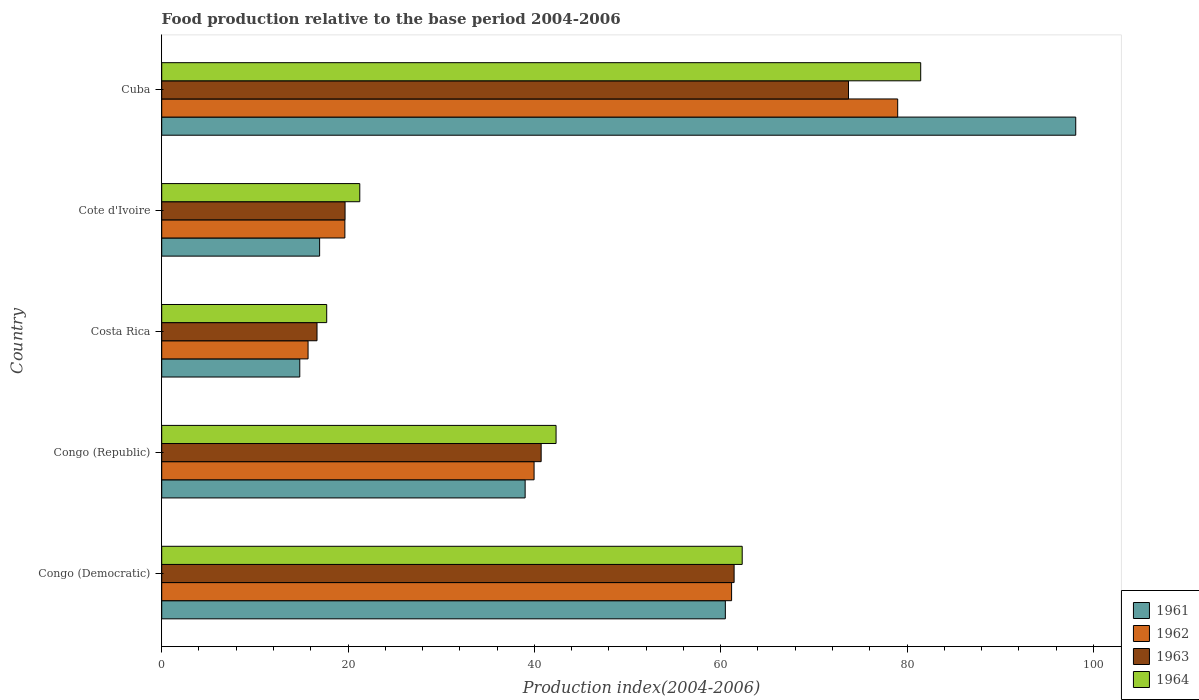How many different coloured bars are there?
Your answer should be compact. 4. How many groups of bars are there?
Make the answer very short. 5. Are the number of bars on each tick of the Y-axis equal?
Offer a very short reply. Yes. How many bars are there on the 2nd tick from the top?
Make the answer very short. 4. What is the label of the 1st group of bars from the top?
Provide a short and direct response. Cuba. In how many cases, is the number of bars for a given country not equal to the number of legend labels?
Give a very brief answer. 0. What is the food production index in 1964 in Cuba?
Provide a short and direct response. 81.47. Across all countries, what is the maximum food production index in 1962?
Provide a short and direct response. 79. Across all countries, what is the minimum food production index in 1962?
Make the answer very short. 15.71. In which country was the food production index in 1964 maximum?
Provide a succinct answer. Cuba. What is the total food production index in 1963 in the graph?
Provide a succinct answer. 212.24. What is the difference between the food production index in 1963 in Congo (Democratic) and that in Cuba?
Keep it short and to the point. -12.28. What is the difference between the food production index in 1964 in Congo (Democratic) and the food production index in 1961 in Cote d'Ivoire?
Offer a very short reply. 45.36. What is the average food production index in 1964 per country?
Your answer should be compact. 45.02. What is the difference between the food production index in 1961 and food production index in 1962 in Cuba?
Ensure brevity in your answer.  19.11. In how many countries, is the food production index in 1961 greater than 28 ?
Provide a short and direct response. 3. What is the ratio of the food production index in 1964 in Congo (Republic) to that in Cote d'Ivoire?
Keep it short and to the point. 1.99. Is the difference between the food production index in 1961 in Costa Rica and Cote d'Ivoire greater than the difference between the food production index in 1962 in Costa Rica and Cote d'Ivoire?
Ensure brevity in your answer.  Yes. What is the difference between the highest and the second highest food production index in 1962?
Ensure brevity in your answer.  17.83. What is the difference between the highest and the lowest food production index in 1963?
Keep it short and to the point. 57.05. In how many countries, is the food production index in 1961 greater than the average food production index in 1961 taken over all countries?
Your response must be concise. 2. Is the sum of the food production index in 1961 in Congo (Democratic) and Costa Rica greater than the maximum food production index in 1963 across all countries?
Provide a short and direct response. Yes. What does the 3rd bar from the bottom in Costa Rica represents?
Provide a short and direct response. 1963. How many bars are there?
Provide a short and direct response. 20. Does the graph contain any zero values?
Offer a very short reply. No. Does the graph contain grids?
Your answer should be very brief. No. How many legend labels are there?
Offer a terse response. 4. How are the legend labels stacked?
Keep it short and to the point. Vertical. What is the title of the graph?
Offer a terse response. Food production relative to the base period 2004-2006. Does "2000" appear as one of the legend labels in the graph?
Offer a terse response. No. What is the label or title of the X-axis?
Keep it short and to the point. Production index(2004-2006). What is the Production index(2004-2006) of 1961 in Congo (Democratic)?
Make the answer very short. 60.5. What is the Production index(2004-2006) in 1962 in Congo (Democratic)?
Your answer should be very brief. 61.17. What is the Production index(2004-2006) in 1963 in Congo (Democratic)?
Offer a very short reply. 61.44. What is the Production index(2004-2006) in 1964 in Congo (Democratic)?
Keep it short and to the point. 62.31. What is the Production index(2004-2006) in 1961 in Congo (Republic)?
Your answer should be very brief. 39.01. What is the Production index(2004-2006) of 1962 in Congo (Republic)?
Your answer should be compact. 39.97. What is the Production index(2004-2006) in 1963 in Congo (Republic)?
Give a very brief answer. 40.73. What is the Production index(2004-2006) in 1964 in Congo (Republic)?
Give a very brief answer. 42.33. What is the Production index(2004-2006) of 1961 in Costa Rica?
Give a very brief answer. 14.82. What is the Production index(2004-2006) of 1962 in Costa Rica?
Offer a very short reply. 15.71. What is the Production index(2004-2006) in 1963 in Costa Rica?
Your answer should be compact. 16.67. What is the Production index(2004-2006) in 1964 in Costa Rica?
Offer a terse response. 17.71. What is the Production index(2004-2006) in 1961 in Cote d'Ivoire?
Your answer should be very brief. 16.95. What is the Production index(2004-2006) of 1962 in Cote d'Ivoire?
Offer a very short reply. 19.66. What is the Production index(2004-2006) in 1963 in Cote d'Ivoire?
Provide a short and direct response. 19.68. What is the Production index(2004-2006) of 1964 in Cote d'Ivoire?
Ensure brevity in your answer.  21.26. What is the Production index(2004-2006) of 1961 in Cuba?
Ensure brevity in your answer.  98.11. What is the Production index(2004-2006) in 1962 in Cuba?
Your answer should be compact. 79. What is the Production index(2004-2006) of 1963 in Cuba?
Your response must be concise. 73.72. What is the Production index(2004-2006) of 1964 in Cuba?
Offer a very short reply. 81.47. Across all countries, what is the maximum Production index(2004-2006) of 1961?
Your answer should be very brief. 98.11. Across all countries, what is the maximum Production index(2004-2006) in 1962?
Offer a very short reply. 79. Across all countries, what is the maximum Production index(2004-2006) of 1963?
Your response must be concise. 73.72. Across all countries, what is the maximum Production index(2004-2006) of 1964?
Keep it short and to the point. 81.47. Across all countries, what is the minimum Production index(2004-2006) of 1961?
Provide a short and direct response. 14.82. Across all countries, what is the minimum Production index(2004-2006) in 1962?
Provide a short and direct response. 15.71. Across all countries, what is the minimum Production index(2004-2006) of 1963?
Ensure brevity in your answer.  16.67. Across all countries, what is the minimum Production index(2004-2006) of 1964?
Make the answer very short. 17.71. What is the total Production index(2004-2006) of 1961 in the graph?
Give a very brief answer. 229.39. What is the total Production index(2004-2006) of 1962 in the graph?
Give a very brief answer. 215.51. What is the total Production index(2004-2006) of 1963 in the graph?
Offer a very short reply. 212.24. What is the total Production index(2004-2006) of 1964 in the graph?
Make the answer very short. 225.08. What is the difference between the Production index(2004-2006) in 1961 in Congo (Democratic) and that in Congo (Republic)?
Offer a terse response. 21.49. What is the difference between the Production index(2004-2006) in 1962 in Congo (Democratic) and that in Congo (Republic)?
Provide a succinct answer. 21.2. What is the difference between the Production index(2004-2006) of 1963 in Congo (Democratic) and that in Congo (Republic)?
Make the answer very short. 20.71. What is the difference between the Production index(2004-2006) in 1964 in Congo (Democratic) and that in Congo (Republic)?
Your response must be concise. 19.98. What is the difference between the Production index(2004-2006) in 1961 in Congo (Democratic) and that in Costa Rica?
Your response must be concise. 45.68. What is the difference between the Production index(2004-2006) of 1962 in Congo (Democratic) and that in Costa Rica?
Your answer should be very brief. 45.46. What is the difference between the Production index(2004-2006) of 1963 in Congo (Democratic) and that in Costa Rica?
Give a very brief answer. 44.77. What is the difference between the Production index(2004-2006) in 1964 in Congo (Democratic) and that in Costa Rica?
Provide a succinct answer. 44.6. What is the difference between the Production index(2004-2006) of 1961 in Congo (Democratic) and that in Cote d'Ivoire?
Offer a terse response. 43.55. What is the difference between the Production index(2004-2006) of 1962 in Congo (Democratic) and that in Cote d'Ivoire?
Offer a very short reply. 41.51. What is the difference between the Production index(2004-2006) in 1963 in Congo (Democratic) and that in Cote d'Ivoire?
Offer a very short reply. 41.76. What is the difference between the Production index(2004-2006) of 1964 in Congo (Democratic) and that in Cote d'Ivoire?
Your answer should be compact. 41.05. What is the difference between the Production index(2004-2006) of 1961 in Congo (Democratic) and that in Cuba?
Make the answer very short. -37.61. What is the difference between the Production index(2004-2006) in 1962 in Congo (Democratic) and that in Cuba?
Your answer should be very brief. -17.83. What is the difference between the Production index(2004-2006) in 1963 in Congo (Democratic) and that in Cuba?
Make the answer very short. -12.28. What is the difference between the Production index(2004-2006) in 1964 in Congo (Democratic) and that in Cuba?
Your answer should be very brief. -19.16. What is the difference between the Production index(2004-2006) in 1961 in Congo (Republic) and that in Costa Rica?
Offer a terse response. 24.19. What is the difference between the Production index(2004-2006) of 1962 in Congo (Republic) and that in Costa Rica?
Your response must be concise. 24.26. What is the difference between the Production index(2004-2006) of 1963 in Congo (Republic) and that in Costa Rica?
Provide a succinct answer. 24.06. What is the difference between the Production index(2004-2006) in 1964 in Congo (Republic) and that in Costa Rica?
Your answer should be very brief. 24.62. What is the difference between the Production index(2004-2006) in 1961 in Congo (Republic) and that in Cote d'Ivoire?
Ensure brevity in your answer.  22.06. What is the difference between the Production index(2004-2006) in 1962 in Congo (Republic) and that in Cote d'Ivoire?
Your answer should be compact. 20.31. What is the difference between the Production index(2004-2006) in 1963 in Congo (Republic) and that in Cote d'Ivoire?
Provide a short and direct response. 21.05. What is the difference between the Production index(2004-2006) of 1964 in Congo (Republic) and that in Cote d'Ivoire?
Offer a very short reply. 21.07. What is the difference between the Production index(2004-2006) of 1961 in Congo (Republic) and that in Cuba?
Your answer should be compact. -59.1. What is the difference between the Production index(2004-2006) in 1962 in Congo (Republic) and that in Cuba?
Your answer should be very brief. -39.03. What is the difference between the Production index(2004-2006) of 1963 in Congo (Republic) and that in Cuba?
Offer a terse response. -32.99. What is the difference between the Production index(2004-2006) of 1964 in Congo (Republic) and that in Cuba?
Offer a very short reply. -39.14. What is the difference between the Production index(2004-2006) in 1961 in Costa Rica and that in Cote d'Ivoire?
Provide a succinct answer. -2.13. What is the difference between the Production index(2004-2006) in 1962 in Costa Rica and that in Cote d'Ivoire?
Offer a very short reply. -3.95. What is the difference between the Production index(2004-2006) of 1963 in Costa Rica and that in Cote d'Ivoire?
Provide a short and direct response. -3.01. What is the difference between the Production index(2004-2006) of 1964 in Costa Rica and that in Cote d'Ivoire?
Your answer should be compact. -3.55. What is the difference between the Production index(2004-2006) in 1961 in Costa Rica and that in Cuba?
Give a very brief answer. -83.29. What is the difference between the Production index(2004-2006) in 1962 in Costa Rica and that in Cuba?
Your answer should be compact. -63.29. What is the difference between the Production index(2004-2006) of 1963 in Costa Rica and that in Cuba?
Offer a terse response. -57.05. What is the difference between the Production index(2004-2006) in 1964 in Costa Rica and that in Cuba?
Your response must be concise. -63.76. What is the difference between the Production index(2004-2006) in 1961 in Cote d'Ivoire and that in Cuba?
Provide a short and direct response. -81.16. What is the difference between the Production index(2004-2006) in 1962 in Cote d'Ivoire and that in Cuba?
Provide a short and direct response. -59.34. What is the difference between the Production index(2004-2006) in 1963 in Cote d'Ivoire and that in Cuba?
Ensure brevity in your answer.  -54.04. What is the difference between the Production index(2004-2006) in 1964 in Cote d'Ivoire and that in Cuba?
Provide a short and direct response. -60.21. What is the difference between the Production index(2004-2006) in 1961 in Congo (Democratic) and the Production index(2004-2006) in 1962 in Congo (Republic)?
Provide a short and direct response. 20.53. What is the difference between the Production index(2004-2006) in 1961 in Congo (Democratic) and the Production index(2004-2006) in 1963 in Congo (Republic)?
Provide a short and direct response. 19.77. What is the difference between the Production index(2004-2006) of 1961 in Congo (Democratic) and the Production index(2004-2006) of 1964 in Congo (Republic)?
Give a very brief answer. 18.17. What is the difference between the Production index(2004-2006) of 1962 in Congo (Democratic) and the Production index(2004-2006) of 1963 in Congo (Republic)?
Ensure brevity in your answer.  20.44. What is the difference between the Production index(2004-2006) of 1962 in Congo (Democratic) and the Production index(2004-2006) of 1964 in Congo (Republic)?
Your answer should be very brief. 18.84. What is the difference between the Production index(2004-2006) of 1963 in Congo (Democratic) and the Production index(2004-2006) of 1964 in Congo (Republic)?
Provide a succinct answer. 19.11. What is the difference between the Production index(2004-2006) in 1961 in Congo (Democratic) and the Production index(2004-2006) in 1962 in Costa Rica?
Give a very brief answer. 44.79. What is the difference between the Production index(2004-2006) in 1961 in Congo (Democratic) and the Production index(2004-2006) in 1963 in Costa Rica?
Provide a succinct answer. 43.83. What is the difference between the Production index(2004-2006) in 1961 in Congo (Democratic) and the Production index(2004-2006) in 1964 in Costa Rica?
Offer a terse response. 42.79. What is the difference between the Production index(2004-2006) of 1962 in Congo (Democratic) and the Production index(2004-2006) of 1963 in Costa Rica?
Give a very brief answer. 44.5. What is the difference between the Production index(2004-2006) in 1962 in Congo (Democratic) and the Production index(2004-2006) in 1964 in Costa Rica?
Your answer should be very brief. 43.46. What is the difference between the Production index(2004-2006) of 1963 in Congo (Democratic) and the Production index(2004-2006) of 1964 in Costa Rica?
Offer a terse response. 43.73. What is the difference between the Production index(2004-2006) of 1961 in Congo (Democratic) and the Production index(2004-2006) of 1962 in Cote d'Ivoire?
Provide a succinct answer. 40.84. What is the difference between the Production index(2004-2006) in 1961 in Congo (Democratic) and the Production index(2004-2006) in 1963 in Cote d'Ivoire?
Your answer should be compact. 40.82. What is the difference between the Production index(2004-2006) of 1961 in Congo (Democratic) and the Production index(2004-2006) of 1964 in Cote d'Ivoire?
Keep it short and to the point. 39.24. What is the difference between the Production index(2004-2006) in 1962 in Congo (Democratic) and the Production index(2004-2006) in 1963 in Cote d'Ivoire?
Offer a terse response. 41.49. What is the difference between the Production index(2004-2006) in 1962 in Congo (Democratic) and the Production index(2004-2006) in 1964 in Cote d'Ivoire?
Offer a terse response. 39.91. What is the difference between the Production index(2004-2006) in 1963 in Congo (Democratic) and the Production index(2004-2006) in 1964 in Cote d'Ivoire?
Your response must be concise. 40.18. What is the difference between the Production index(2004-2006) of 1961 in Congo (Democratic) and the Production index(2004-2006) of 1962 in Cuba?
Offer a terse response. -18.5. What is the difference between the Production index(2004-2006) of 1961 in Congo (Democratic) and the Production index(2004-2006) of 1963 in Cuba?
Offer a terse response. -13.22. What is the difference between the Production index(2004-2006) in 1961 in Congo (Democratic) and the Production index(2004-2006) in 1964 in Cuba?
Your answer should be very brief. -20.97. What is the difference between the Production index(2004-2006) of 1962 in Congo (Democratic) and the Production index(2004-2006) of 1963 in Cuba?
Offer a very short reply. -12.55. What is the difference between the Production index(2004-2006) in 1962 in Congo (Democratic) and the Production index(2004-2006) in 1964 in Cuba?
Offer a very short reply. -20.3. What is the difference between the Production index(2004-2006) in 1963 in Congo (Democratic) and the Production index(2004-2006) in 1964 in Cuba?
Offer a very short reply. -20.03. What is the difference between the Production index(2004-2006) in 1961 in Congo (Republic) and the Production index(2004-2006) in 1962 in Costa Rica?
Keep it short and to the point. 23.3. What is the difference between the Production index(2004-2006) of 1961 in Congo (Republic) and the Production index(2004-2006) of 1963 in Costa Rica?
Offer a terse response. 22.34. What is the difference between the Production index(2004-2006) in 1961 in Congo (Republic) and the Production index(2004-2006) in 1964 in Costa Rica?
Your response must be concise. 21.3. What is the difference between the Production index(2004-2006) of 1962 in Congo (Republic) and the Production index(2004-2006) of 1963 in Costa Rica?
Provide a succinct answer. 23.3. What is the difference between the Production index(2004-2006) in 1962 in Congo (Republic) and the Production index(2004-2006) in 1964 in Costa Rica?
Your response must be concise. 22.26. What is the difference between the Production index(2004-2006) of 1963 in Congo (Republic) and the Production index(2004-2006) of 1964 in Costa Rica?
Keep it short and to the point. 23.02. What is the difference between the Production index(2004-2006) of 1961 in Congo (Republic) and the Production index(2004-2006) of 1962 in Cote d'Ivoire?
Provide a short and direct response. 19.35. What is the difference between the Production index(2004-2006) in 1961 in Congo (Republic) and the Production index(2004-2006) in 1963 in Cote d'Ivoire?
Your answer should be very brief. 19.33. What is the difference between the Production index(2004-2006) of 1961 in Congo (Republic) and the Production index(2004-2006) of 1964 in Cote d'Ivoire?
Provide a succinct answer. 17.75. What is the difference between the Production index(2004-2006) of 1962 in Congo (Republic) and the Production index(2004-2006) of 1963 in Cote d'Ivoire?
Make the answer very short. 20.29. What is the difference between the Production index(2004-2006) in 1962 in Congo (Republic) and the Production index(2004-2006) in 1964 in Cote d'Ivoire?
Your answer should be compact. 18.71. What is the difference between the Production index(2004-2006) of 1963 in Congo (Republic) and the Production index(2004-2006) of 1964 in Cote d'Ivoire?
Ensure brevity in your answer.  19.47. What is the difference between the Production index(2004-2006) of 1961 in Congo (Republic) and the Production index(2004-2006) of 1962 in Cuba?
Your answer should be very brief. -39.99. What is the difference between the Production index(2004-2006) of 1961 in Congo (Republic) and the Production index(2004-2006) of 1963 in Cuba?
Provide a succinct answer. -34.71. What is the difference between the Production index(2004-2006) in 1961 in Congo (Republic) and the Production index(2004-2006) in 1964 in Cuba?
Offer a terse response. -42.46. What is the difference between the Production index(2004-2006) in 1962 in Congo (Republic) and the Production index(2004-2006) in 1963 in Cuba?
Your answer should be compact. -33.75. What is the difference between the Production index(2004-2006) in 1962 in Congo (Republic) and the Production index(2004-2006) in 1964 in Cuba?
Keep it short and to the point. -41.5. What is the difference between the Production index(2004-2006) in 1963 in Congo (Republic) and the Production index(2004-2006) in 1964 in Cuba?
Your answer should be very brief. -40.74. What is the difference between the Production index(2004-2006) of 1961 in Costa Rica and the Production index(2004-2006) of 1962 in Cote d'Ivoire?
Provide a short and direct response. -4.84. What is the difference between the Production index(2004-2006) in 1961 in Costa Rica and the Production index(2004-2006) in 1963 in Cote d'Ivoire?
Your answer should be compact. -4.86. What is the difference between the Production index(2004-2006) in 1961 in Costa Rica and the Production index(2004-2006) in 1964 in Cote d'Ivoire?
Make the answer very short. -6.44. What is the difference between the Production index(2004-2006) in 1962 in Costa Rica and the Production index(2004-2006) in 1963 in Cote d'Ivoire?
Provide a short and direct response. -3.97. What is the difference between the Production index(2004-2006) in 1962 in Costa Rica and the Production index(2004-2006) in 1964 in Cote d'Ivoire?
Provide a succinct answer. -5.55. What is the difference between the Production index(2004-2006) in 1963 in Costa Rica and the Production index(2004-2006) in 1964 in Cote d'Ivoire?
Make the answer very short. -4.59. What is the difference between the Production index(2004-2006) in 1961 in Costa Rica and the Production index(2004-2006) in 1962 in Cuba?
Make the answer very short. -64.18. What is the difference between the Production index(2004-2006) in 1961 in Costa Rica and the Production index(2004-2006) in 1963 in Cuba?
Your response must be concise. -58.9. What is the difference between the Production index(2004-2006) in 1961 in Costa Rica and the Production index(2004-2006) in 1964 in Cuba?
Ensure brevity in your answer.  -66.65. What is the difference between the Production index(2004-2006) of 1962 in Costa Rica and the Production index(2004-2006) of 1963 in Cuba?
Offer a very short reply. -58.01. What is the difference between the Production index(2004-2006) in 1962 in Costa Rica and the Production index(2004-2006) in 1964 in Cuba?
Give a very brief answer. -65.76. What is the difference between the Production index(2004-2006) of 1963 in Costa Rica and the Production index(2004-2006) of 1964 in Cuba?
Your answer should be compact. -64.8. What is the difference between the Production index(2004-2006) in 1961 in Cote d'Ivoire and the Production index(2004-2006) in 1962 in Cuba?
Offer a very short reply. -62.05. What is the difference between the Production index(2004-2006) of 1961 in Cote d'Ivoire and the Production index(2004-2006) of 1963 in Cuba?
Ensure brevity in your answer.  -56.77. What is the difference between the Production index(2004-2006) in 1961 in Cote d'Ivoire and the Production index(2004-2006) in 1964 in Cuba?
Your answer should be very brief. -64.52. What is the difference between the Production index(2004-2006) in 1962 in Cote d'Ivoire and the Production index(2004-2006) in 1963 in Cuba?
Offer a terse response. -54.06. What is the difference between the Production index(2004-2006) in 1962 in Cote d'Ivoire and the Production index(2004-2006) in 1964 in Cuba?
Give a very brief answer. -61.81. What is the difference between the Production index(2004-2006) of 1963 in Cote d'Ivoire and the Production index(2004-2006) of 1964 in Cuba?
Your answer should be compact. -61.79. What is the average Production index(2004-2006) of 1961 per country?
Your answer should be very brief. 45.88. What is the average Production index(2004-2006) of 1962 per country?
Make the answer very short. 43.1. What is the average Production index(2004-2006) in 1963 per country?
Offer a very short reply. 42.45. What is the average Production index(2004-2006) of 1964 per country?
Give a very brief answer. 45.02. What is the difference between the Production index(2004-2006) in 1961 and Production index(2004-2006) in 1962 in Congo (Democratic)?
Ensure brevity in your answer.  -0.67. What is the difference between the Production index(2004-2006) of 1961 and Production index(2004-2006) of 1963 in Congo (Democratic)?
Your response must be concise. -0.94. What is the difference between the Production index(2004-2006) in 1961 and Production index(2004-2006) in 1964 in Congo (Democratic)?
Your answer should be compact. -1.81. What is the difference between the Production index(2004-2006) in 1962 and Production index(2004-2006) in 1963 in Congo (Democratic)?
Your answer should be very brief. -0.27. What is the difference between the Production index(2004-2006) of 1962 and Production index(2004-2006) of 1964 in Congo (Democratic)?
Offer a terse response. -1.14. What is the difference between the Production index(2004-2006) in 1963 and Production index(2004-2006) in 1964 in Congo (Democratic)?
Offer a terse response. -0.87. What is the difference between the Production index(2004-2006) of 1961 and Production index(2004-2006) of 1962 in Congo (Republic)?
Your answer should be compact. -0.96. What is the difference between the Production index(2004-2006) in 1961 and Production index(2004-2006) in 1963 in Congo (Republic)?
Your answer should be very brief. -1.72. What is the difference between the Production index(2004-2006) of 1961 and Production index(2004-2006) of 1964 in Congo (Republic)?
Offer a very short reply. -3.32. What is the difference between the Production index(2004-2006) in 1962 and Production index(2004-2006) in 1963 in Congo (Republic)?
Offer a terse response. -0.76. What is the difference between the Production index(2004-2006) of 1962 and Production index(2004-2006) of 1964 in Congo (Republic)?
Provide a short and direct response. -2.36. What is the difference between the Production index(2004-2006) of 1963 and Production index(2004-2006) of 1964 in Congo (Republic)?
Your answer should be compact. -1.6. What is the difference between the Production index(2004-2006) of 1961 and Production index(2004-2006) of 1962 in Costa Rica?
Keep it short and to the point. -0.89. What is the difference between the Production index(2004-2006) of 1961 and Production index(2004-2006) of 1963 in Costa Rica?
Provide a succinct answer. -1.85. What is the difference between the Production index(2004-2006) in 1961 and Production index(2004-2006) in 1964 in Costa Rica?
Ensure brevity in your answer.  -2.89. What is the difference between the Production index(2004-2006) of 1962 and Production index(2004-2006) of 1963 in Costa Rica?
Your response must be concise. -0.96. What is the difference between the Production index(2004-2006) of 1962 and Production index(2004-2006) of 1964 in Costa Rica?
Your response must be concise. -2. What is the difference between the Production index(2004-2006) in 1963 and Production index(2004-2006) in 1964 in Costa Rica?
Give a very brief answer. -1.04. What is the difference between the Production index(2004-2006) in 1961 and Production index(2004-2006) in 1962 in Cote d'Ivoire?
Your answer should be very brief. -2.71. What is the difference between the Production index(2004-2006) of 1961 and Production index(2004-2006) of 1963 in Cote d'Ivoire?
Your answer should be compact. -2.73. What is the difference between the Production index(2004-2006) of 1961 and Production index(2004-2006) of 1964 in Cote d'Ivoire?
Offer a very short reply. -4.31. What is the difference between the Production index(2004-2006) of 1962 and Production index(2004-2006) of 1963 in Cote d'Ivoire?
Provide a short and direct response. -0.02. What is the difference between the Production index(2004-2006) of 1962 and Production index(2004-2006) of 1964 in Cote d'Ivoire?
Provide a succinct answer. -1.6. What is the difference between the Production index(2004-2006) in 1963 and Production index(2004-2006) in 1964 in Cote d'Ivoire?
Your answer should be very brief. -1.58. What is the difference between the Production index(2004-2006) of 1961 and Production index(2004-2006) of 1962 in Cuba?
Offer a terse response. 19.11. What is the difference between the Production index(2004-2006) in 1961 and Production index(2004-2006) in 1963 in Cuba?
Offer a terse response. 24.39. What is the difference between the Production index(2004-2006) of 1961 and Production index(2004-2006) of 1964 in Cuba?
Your answer should be very brief. 16.64. What is the difference between the Production index(2004-2006) in 1962 and Production index(2004-2006) in 1963 in Cuba?
Offer a terse response. 5.28. What is the difference between the Production index(2004-2006) in 1962 and Production index(2004-2006) in 1964 in Cuba?
Ensure brevity in your answer.  -2.47. What is the difference between the Production index(2004-2006) of 1963 and Production index(2004-2006) of 1964 in Cuba?
Keep it short and to the point. -7.75. What is the ratio of the Production index(2004-2006) of 1961 in Congo (Democratic) to that in Congo (Republic)?
Provide a succinct answer. 1.55. What is the ratio of the Production index(2004-2006) in 1962 in Congo (Democratic) to that in Congo (Republic)?
Your response must be concise. 1.53. What is the ratio of the Production index(2004-2006) in 1963 in Congo (Democratic) to that in Congo (Republic)?
Make the answer very short. 1.51. What is the ratio of the Production index(2004-2006) in 1964 in Congo (Democratic) to that in Congo (Republic)?
Give a very brief answer. 1.47. What is the ratio of the Production index(2004-2006) of 1961 in Congo (Democratic) to that in Costa Rica?
Your response must be concise. 4.08. What is the ratio of the Production index(2004-2006) of 1962 in Congo (Democratic) to that in Costa Rica?
Ensure brevity in your answer.  3.89. What is the ratio of the Production index(2004-2006) of 1963 in Congo (Democratic) to that in Costa Rica?
Ensure brevity in your answer.  3.69. What is the ratio of the Production index(2004-2006) in 1964 in Congo (Democratic) to that in Costa Rica?
Your answer should be very brief. 3.52. What is the ratio of the Production index(2004-2006) in 1961 in Congo (Democratic) to that in Cote d'Ivoire?
Give a very brief answer. 3.57. What is the ratio of the Production index(2004-2006) of 1962 in Congo (Democratic) to that in Cote d'Ivoire?
Ensure brevity in your answer.  3.11. What is the ratio of the Production index(2004-2006) of 1963 in Congo (Democratic) to that in Cote d'Ivoire?
Make the answer very short. 3.12. What is the ratio of the Production index(2004-2006) of 1964 in Congo (Democratic) to that in Cote d'Ivoire?
Provide a short and direct response. 2.93. What is the ratio of the Production index(2004-2006) of 1961 in Congo (Democratic) to that in Cuba?
Offer a terse response. 0.62. What is the ratio of the Production index(2004-2006) of 1962 in Congo (Democratic) to that in Cuba?
Provide a succinct answer. 0.77. What is the ratio of the Production index(2004-2006) of 1963 in Congo (Democratic) to that in Cuba?
Keep it short and to the point. 0.83. What is the ratio of the Production index(2004-2006) in 1964 in Congo (Democratic) to that in Cuba?
Your answer should be very brief. 0.76. What is the ratio of the Production index(2004-2006) of 1961 in Congo (Republic) to that in Costa Rica?
Offer a terse response. 2.63. What is the ratio of the Production index(2004-2006) in 1962 in Congo (Republic) to that in Costa Rica?
Provide a short and direct response. 2.54. What is the ratio of the Production index(2004-2006) of 1963 in Congo (Republic) to that in Costa Rica?
Offer a very short reply. 2.44. What is the ratio of the Production index(2004-2006) in 1964 in Congo (Republic) to that in Costa Rica?
Make the answer very short. 2.39. What is the ratio of the Production index(2004-2006) in 1961 in Congo (Republic) to that in Cote d'Ivoire?
Give a very brief answer. 2.3. What is the ratio of the Production index(2004-2006) of 1962 in Congo (Republic) to that in Cote d'Ivoire?
Ensure brevity in your answer.  2.03. What is the ratio of the Production index(2004-2006) of 1963 in Congo (Republic) to that in Cote d'Ivoire?
Provide a succinct answer. 2.07. What is the ratio of the Production index(2004-2006) of 1964 in Congo (Republic) to that in Cote d'Ivoire?
Your answer should be compact. 1.99. What is the ratio of the Production index(2004-2006) in 1961 in Congo (Republic) to that in Cuba?
Make the answer very short. 0.4. What is the ratio of the Production index(2004-2006) in 1962 in Congo (Republic) to that in Cuba?
Make the answer very short. 0.51. What is the ratio of the Production index(2004-2006) in 1963 in Congo (Republic) to that in Cuba?
Make the answer very short. 0.55. What is the ratio of the Production index(2004-2006) in 1964 in Congo (Republic) to that in Cuba?
Offer a very short reply. 0.52. What is the ratio of the Production index(2004-2006) of 1961 in Costa Rica to that in Cote d'Ivoire?
Your response must be concise. 0.87. What is the ratio of the Production index(2004-2006) of 1962 in Costa Rica to that in Cote d'Ivoire?
Make the answer very short. 0.8. What is the ratio of the Production index(2004-2006) in 1963 in Costa Rica to that in Cote d'Ivoire?
Offer a terse response. 0.85. What is the ratio of the Production index(2004-2006) of 1964 in Costa Rica to that in Cote d'Ivoire?
Provide a short and direct response. 0.83. What is the ratio of the Production index(2004-2006) in 1961 in Costa Rica to that in Cuba?
Provide a short and direct response. 0.15. What is the ratio of the Production index(2004-2006) in 1962 in Costa Rica to that in Cuba?
Offer a terse response. 0.2. What is the ratio of the Production index(2004-2006) in 1963 in Costa Rica to that in Cuba?
Your answer should be very brief. 0.23. What is the ratio of the Production index(2004-2006) of 1964 in Costa Rica to that in Cuba?
Your answer should be very brief. 0.22. What is the ratio of the Production index(2004-2006) in 1961 in Cote d'Ivoire to that in Cuba?
Offer a very short reply. 0.17. What is the ratio of the Production index(2004-2006) of 1962 in Cote d'Ivoire to that in Cuba?
Your answer should be very brief. 0.25. What is the ratio of the Production index(2004-2006) in 1963 in Cote d'Ivoire to that in Cuba?
Your answer should be compact. 0.27. What is the ratio of the Production index(2004-2006) of 1964 in Cote d'Ivoire to that in Cuba?
Your answer should be compact. 0.26. What is the difference between the highest and the second highest Production index(2004-2006) of 1961?
Ensure brevity in your answer.  37.61. What is the difference between the highest and the second highest Production index(2004-2006) in 1962?
Your answer should be very brief. 17.83. What is the difference between the highest and the second highest Production index(2004-2006) of 1963?
Offer a very short reply. 12.28. What is the difference between the highest and the second highest Production index(2004-2006) in 1964?
Your answer should be compact. 19.16. What is the difference between the highest and the lowest Production index(2004-2006) of 1961?
Offer a very short reply. 83.29. What is the difference between the highest and the lowest Production index(2004-2006) in 1962?
Provide a short and direct response. 63.29. What is the difference between the highest and the lowest Production index(2004-2006) of 1963?
Your response must be concise. 57.05. What is the difference between the highest and the lowest Production index(2004-2006) in 1964?
Your answer should be compact. 63.76. 